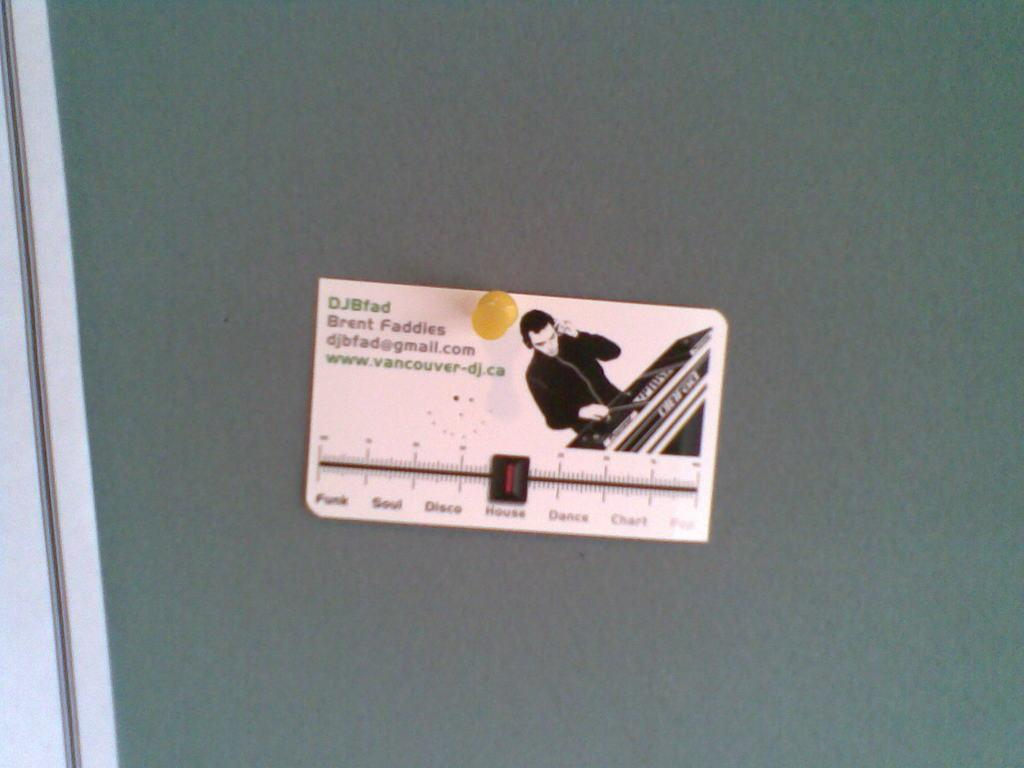What is the primary color of the board in the image? The board in the image is green. How is the board positioned in the image? The board appears to be truncated. What is attached to the board in the image? There is an object pinned to the board. What is the condition of the person sleeping on the board in the image? There is no person sleeping on the board in the image; it only features a green color board with an object pinned to it. 